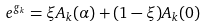Convert formula to latex. <formula><loc_0><loc_0><loc_500><loc_500>e ^ { g _ { k } } = \xi A _ { k } ( \alpha ) + ( 1 - \xi ) A _ { k } ( 0 )</formula> 